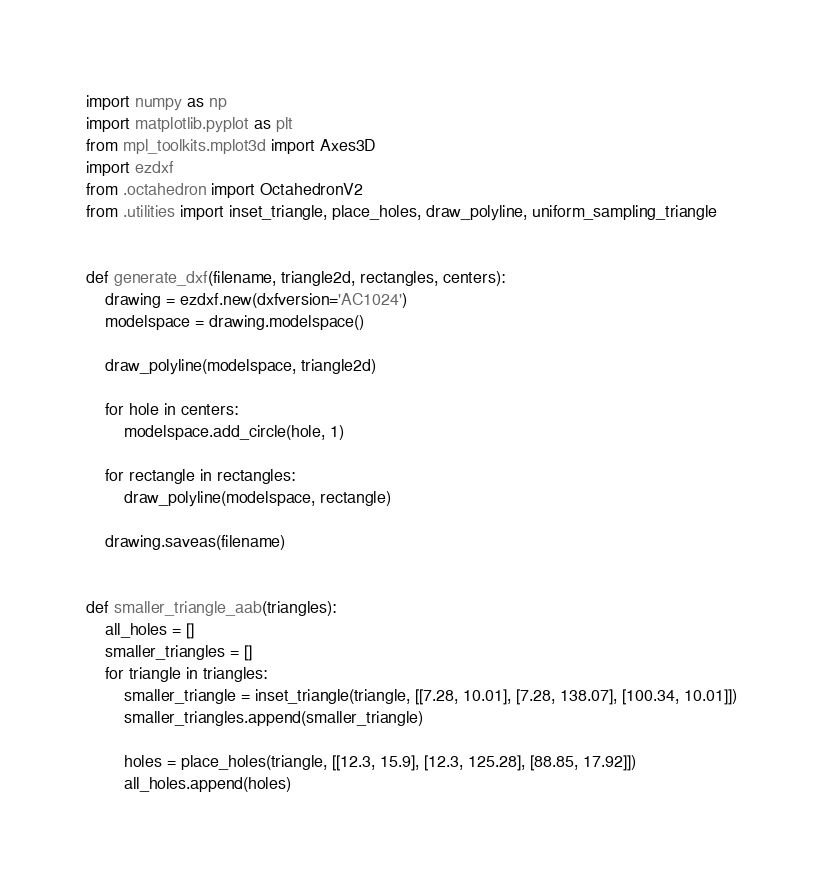Convert code to text. <code><loc_0><loc_0><loc_500><loc_500><_Python_>import numpy as np
import matplotlib.pyplot as plt
from mpl_toolkits.mplot3d import Axes3D
import ezdxf
from .octahedron import OctahedronV2
from .utilities import inset_triangle, place_holes, draw_polyline, uniform_sampling_triangle


def generate_dxf(filename, triangle2d, rectangles, centers):
    drawing = ezdxf.new(dxfversion='AC1024')
    modelspace = drawing.modelspace()

    draw_polyline(modelspace, triangle2d)

    for hole in centers:
        modelspace.add_circle(hole, 1)

    for rectangle in rectangles:
        draw_polyline(modelspace, rectangle)

    drawing.saveas(filename)


def smaller_triangle_aab(triangles):
    all_holes = []
    smaller_triangles = []
    for triangle in triangles:
        smaller_triangle = inset_triangle(triangle, [[7.28, 10.01], [7.28, 138.07], [100.34, 10.01]])
        smaller_triangles.append(smaller_triangle)

        holes = place_holes(triangle, [[12.3, 15.9], [12.3, 125.28], [88.85, 17.92]])
        all_holes.append(holes)</code> 